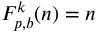Convert formula to latex. <formula><loc_0><loc_0><loc_500><loc_500>F _ { p , b } ^ { k } ( n ) = n</formula> 